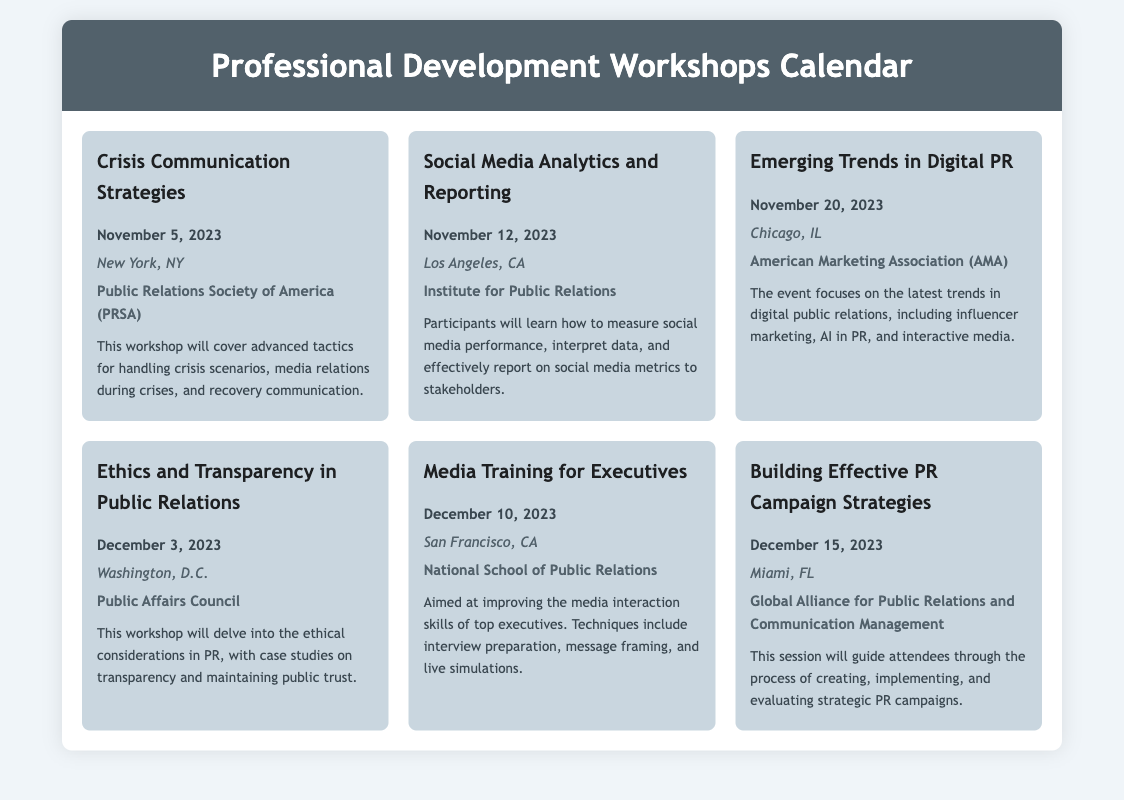What is the date of the workshop on Crisis Communication Strategies? The date for this workshop is stated in the document, which is November 5, 2023.
Answer: November 5, 2023 Who is hosting the Social Media Analytics and Reporting workshop? The host of the workshop can be found in the details of the event, which is the Institute for Public Relations.
Answer: Institute for Public Relations What city will the Ethics and Transparency workshop take place? The location of this workshop is provided in the document, which is Washington, D.C.
Answer: Washington, D.C What is a key topic covered in the Emerging Trends in Digital PR workshop? The description mentions focus areas, particularly influencer marketing, AI in PR, and interactive media.
Answer: Influencer marketing How many workshops are scheduled for December? By counting the number of workshops listed in December from the calendar, there are three workshops scheduled.
Answer: Three Which organization is related to the workshop on Building Effective PR Campaign Strategies? The hosting organization is mentioned in the document as Global Alliance for Public Relations and Communication Management.
Answer: Global Alliance for Public Relations and Communication Management What is the purpose of the Media Training for Executives workshop? The purpose is stated as improving media interaction skills of top executives, including specific techniques.
Answer: Improving media interaction skills What is the description of the workshop on Crisis Communication Strategies? The document provides a specific description, which involves tactics for handling crises and media relations.
Answer: Advanced tactics for handling crisis scenarios, media relations during crises, and recovery communication In which city will the workshop on Social Media Analytics and Reporting be held? The location provided in the document for this workshop is Los Angeles, CA.
Answer: Los Angeles, CA 